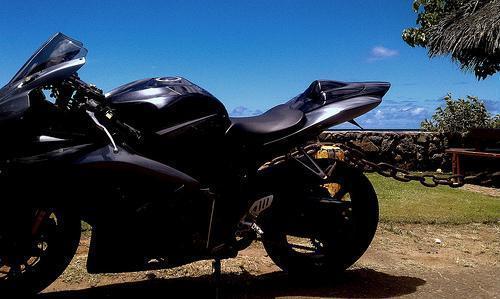How many bikes do you see?
Give a very brief answer. 1. 